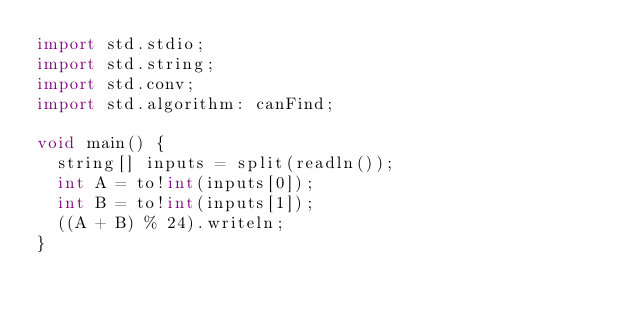Convert code to text. <code><loc_0><loc_0><loc_500><loc_500><_D_>import std.stdio;
import std.string;
import std.conv;
import std.algorithm: canFind;

void main() {
	string[] inputs = split(readln());
	int A = to!int(inputs[0]);
	int B = to!int(inputs[1]);
	((A + B) % 24).writeln;
}
</code> 